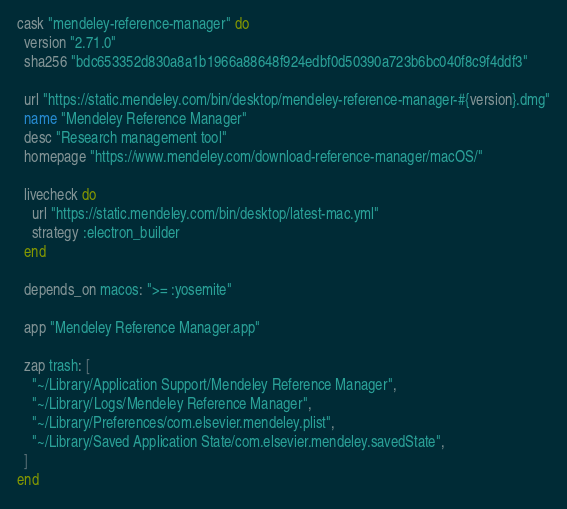<code> <loc_0><loc_0><loc_500><loc_500><_Ruby_>cask "mendeley-reference-manager" do
  version "2.71.0"
  sha256 "bdc653352d830a8a1b1966a88648f924edbf0d50390a723b6bc040f8c9f4ddf3"

  url "https://static.mendeley.com/bin/desktop/mendeley-reference-manager-#{version}.dmg"
  name "Mendeley Reference Manager"
  desc "Research management tool"
  homepage "https://www.mendeley.com/download-reference-manager/macOS/"

  livecheck do
    url "https://static.mendeley.com/bin/desktop/latest-mac.yml"
    strategy :electron_builder
  end

  depends_on macos: ">= :yosemite"

  app "Mendeley Reference Manager.app"

  zap trash: [
    "~/Library/Application Support/Mendeley Reference Manager",
    "~/Library/Logs/Mendeley Reference Manager",
    "~/Library/Preferences/com.elsevier.mendeley.plist",
    "~/Library/Saved Application State/com.elsevier.mendeley.savedState",
  ]
end
</code> 